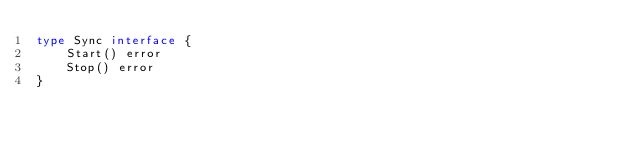<code> <loc_0><loc_0><loc_500><loc_500><_Go_>type Sync interface {
	Start() error
	Stop() error
}
</code> 